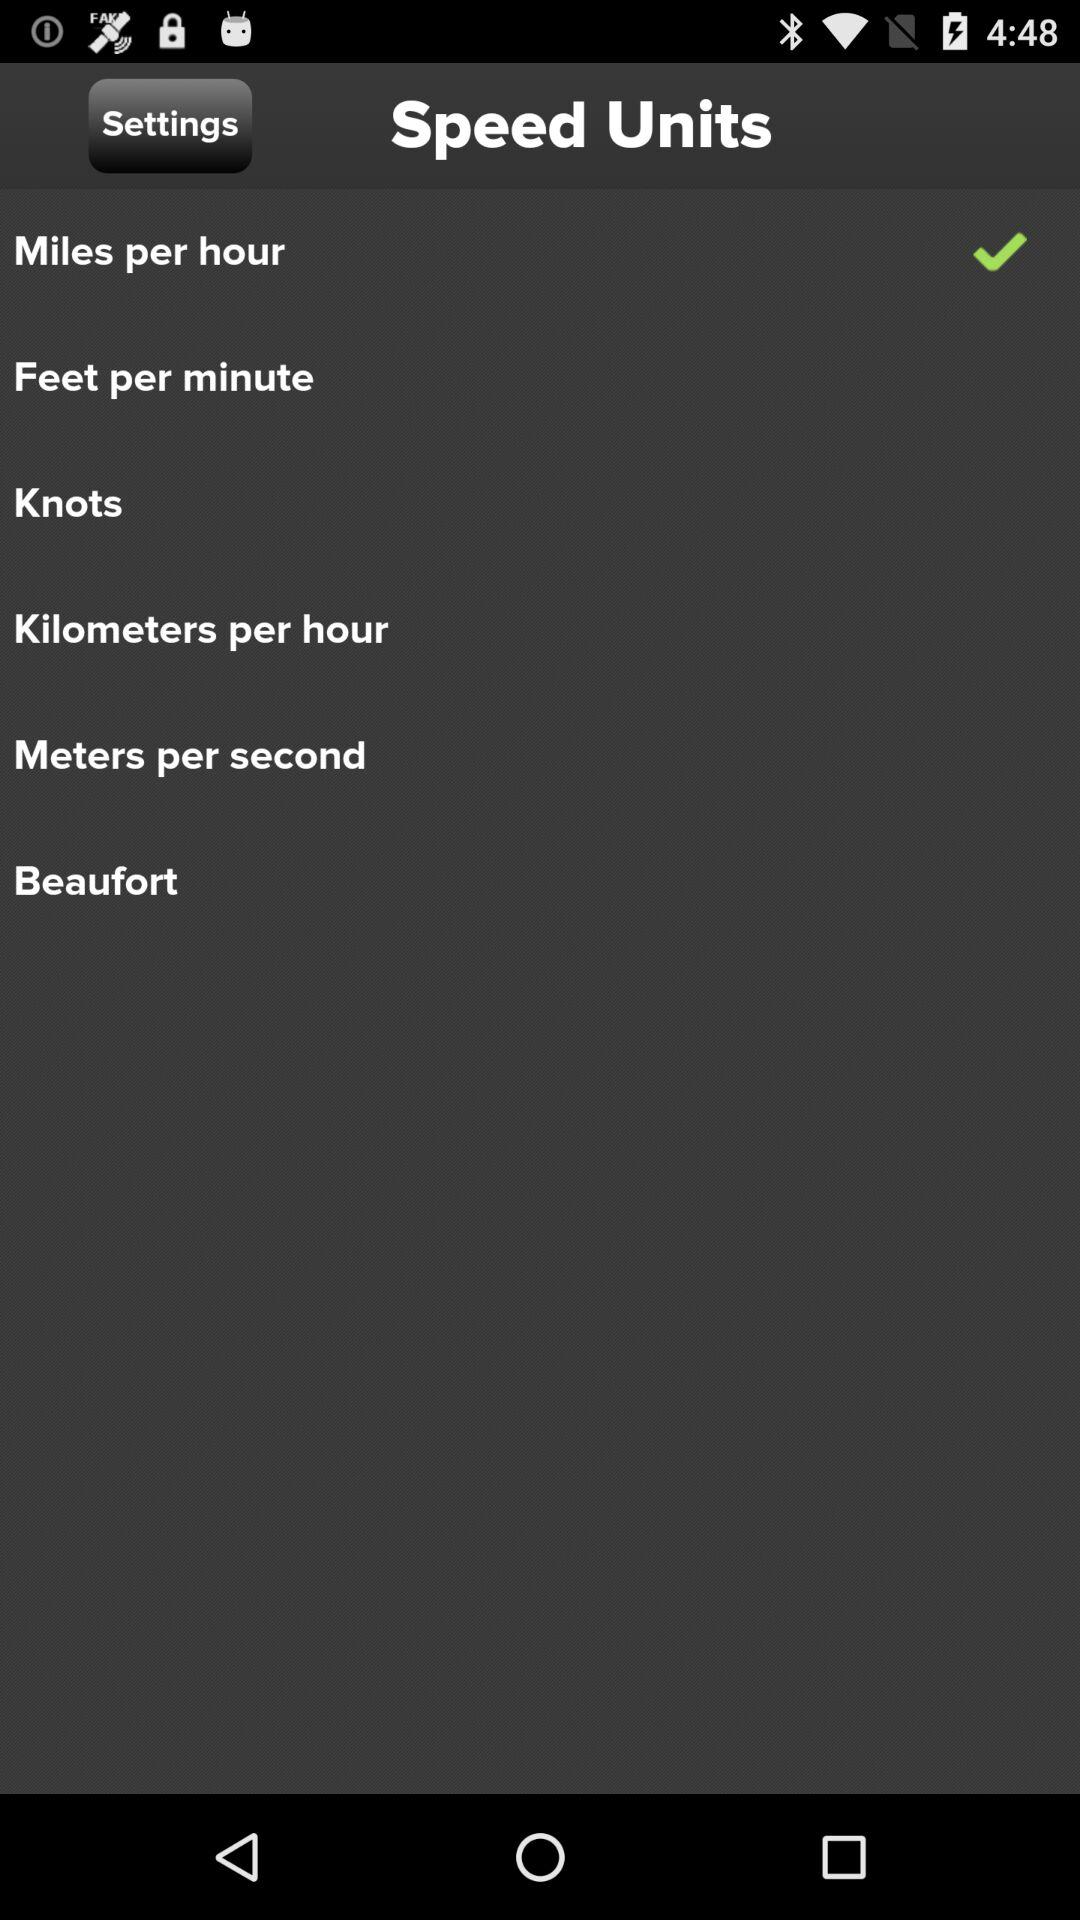Which types of speed units are available? The available types of speed units are miles per hour, feet per minute, knots, kilometers per hour, meters per second and Beaufort. 